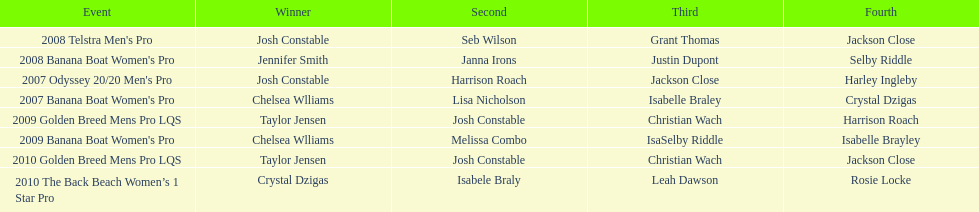Who was the top performer in the 2008 telstra men's pro? Josh Constable. 